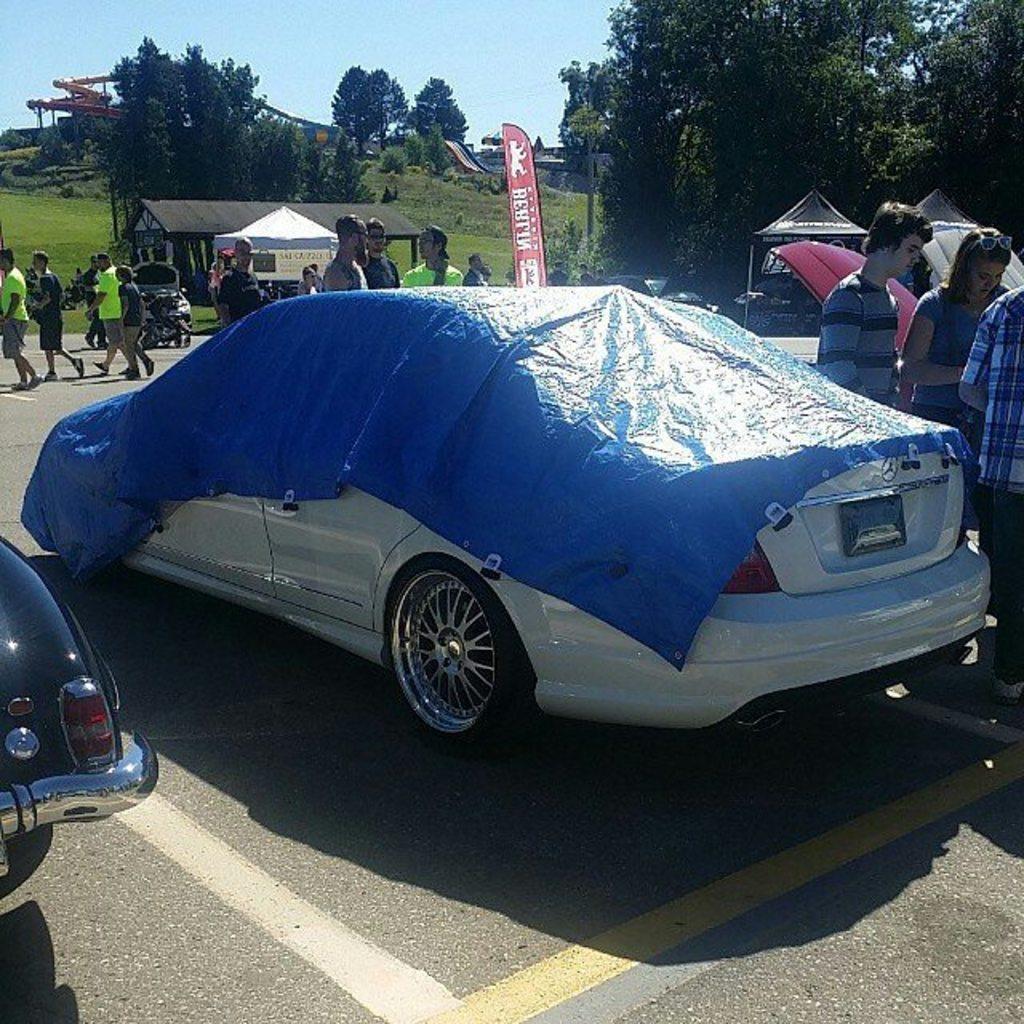In one or two sentences, can you explain what this image depicts? In this image in the center of there are cars on the road and there are persons standing and walking. In the background there are trees, there is grass on the ground and there are tents and there is a cottage. 